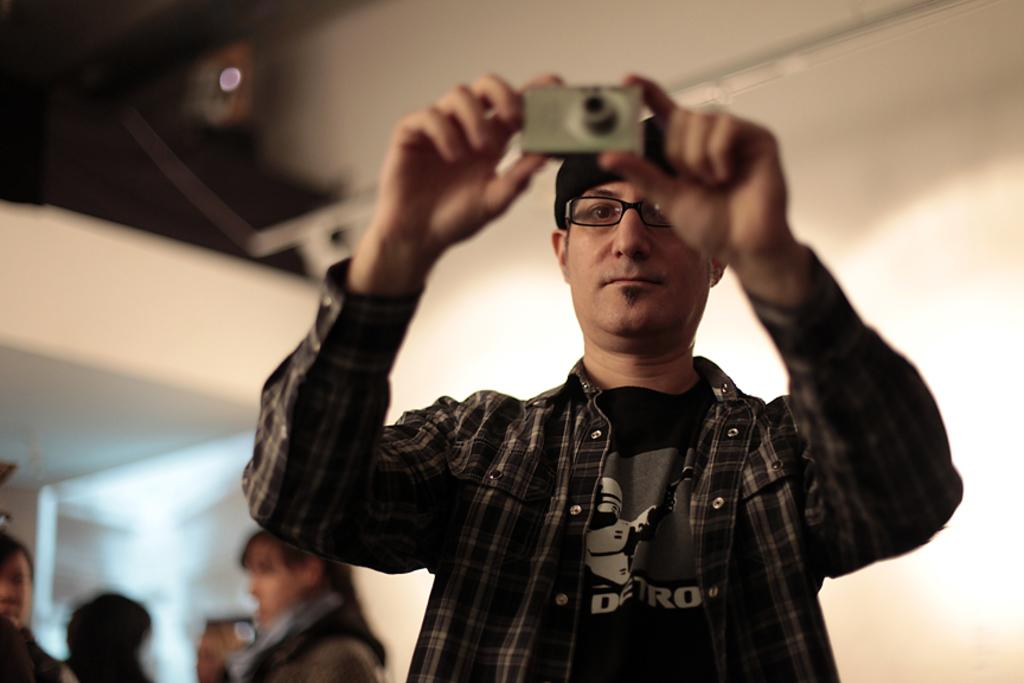What is the man in the image doing? The man is standing in the image and taking a picture. What is the man holding in the image? The man is holding a camera in the image. Can you describe the background of the image? There is a group of people in the background of the image. What type of army is visible in the image? There is no army present in the image. Can you describe the waves in the image? There are no waves present in the image. What kind of wren can be seen in the image? There is no wren present in the image. 